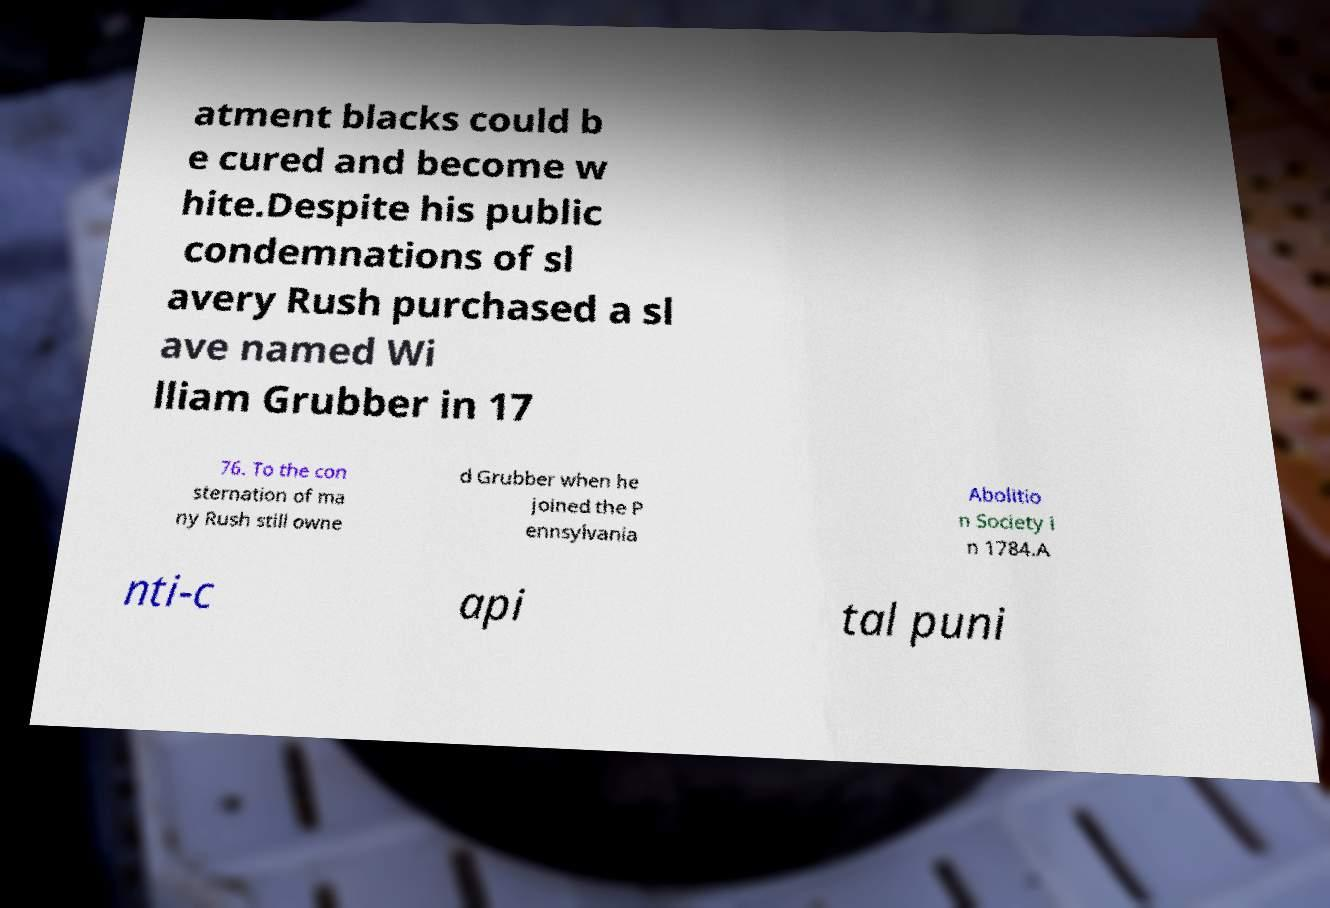Can you read and provide the text displayed in the image?This photo seems to have some interesting text. Can you extract and type it out for me? atment blacks could b e cured and become w hite.Despite his public condemnations of sl avery Rush purchased a sl ave named Wi lliam Grubber in 17 76. To the con sternation of ma ny Rush still owne d Grubber when he joined the P ennsylvania Abolitio n Society i n 1784.A nti-c api tal puni 